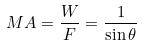<formula> <loc_0><loc_0><loc_500><loc_500>M A = \frac { W } { F } = \frac { 1 } { \sin \theta }</formula> 